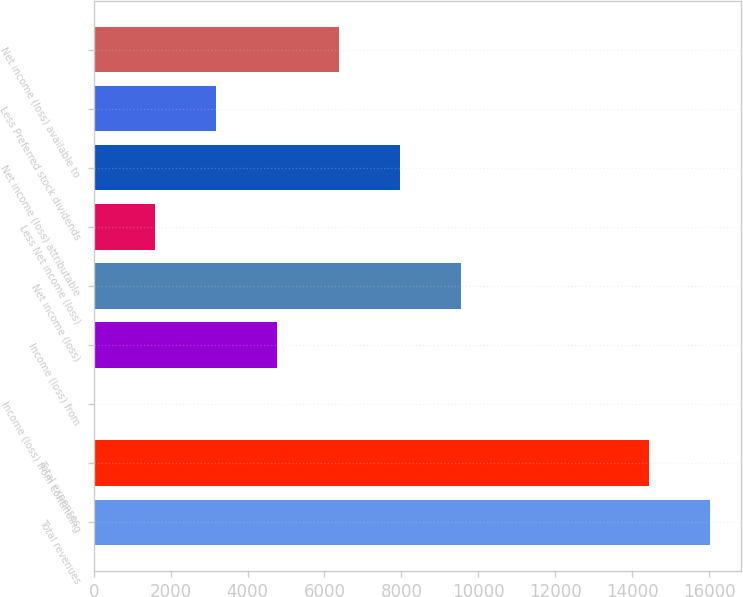<chart> <loc_0><loc_0><loc_500><loc_500><bar_chart><fcel>Total revenues<fcel>Total expenses<fcel>Income (loss) from continuing<fcel>Income (loss) from<fcel>Net income (loss)<fcel>Less Net income (loss)<fcel>Net income (loss) attributable<fcel>Less Preferred stock dividends<fcel>Net income (loss) available to<nl><fcel>16020<fcel>14429<fcel>0.82<fcel>4773.88<fcel>9546.94<fcel>1591.84<fcel>7955.92<fcel>3182.86<fcel>6364.9<nl></chart> 